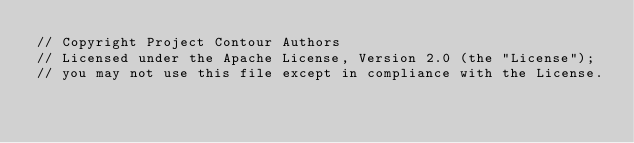Convert code to text. <code><loc_0><loc_0><loc_500><loc_500><_Go_>// Copyright Project Contour Authors
// Licensed under the Apache License, Version 2.0 (the "License");
// you may not use this file except in compliance with the License.</code> 